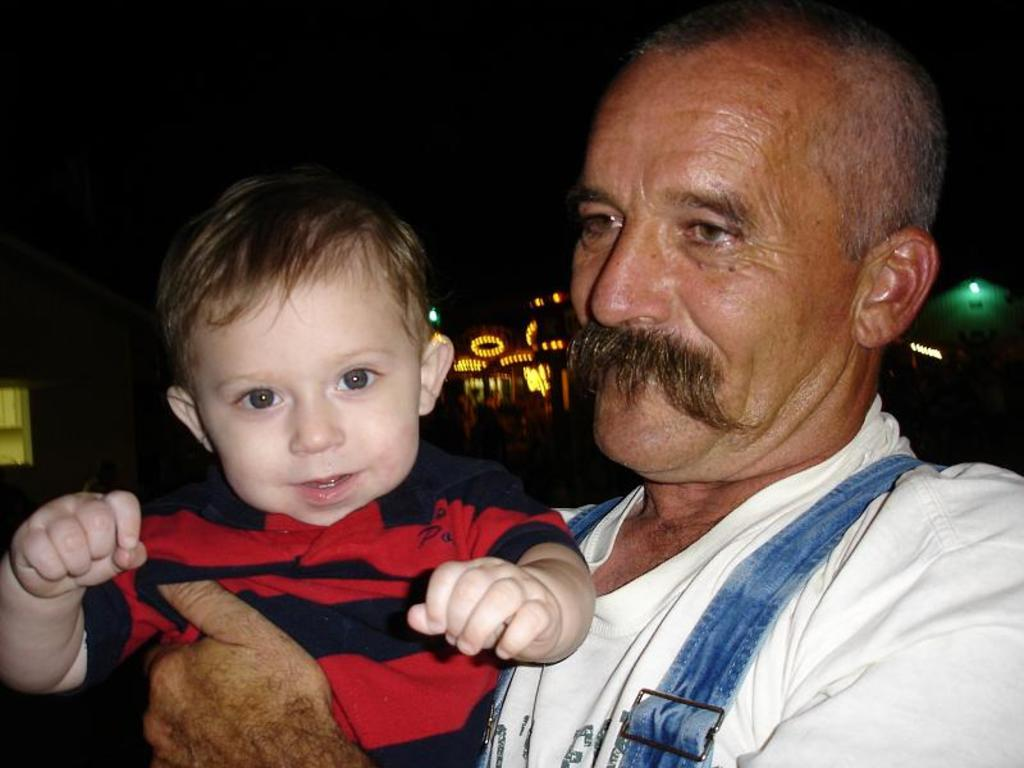What is happening in the image involving the person and the boy? There is a person holding a boy in the image. How are the person and the boy feeling in the image? Both the person and the boy are smiling in the image. What can be seen in the distance behind the person and the boy? There are buildings and lights visible in the background of the image. What type of sail can be seen on the giant's back in the image? There are no giants or sails present in the image; it features a person holding a boy with buildings and lights in the background. What brand of toothpaste is the boy using in the image? There is no toothpaste visible in the image; it only shows a person holding a boy with both of them smiling. 